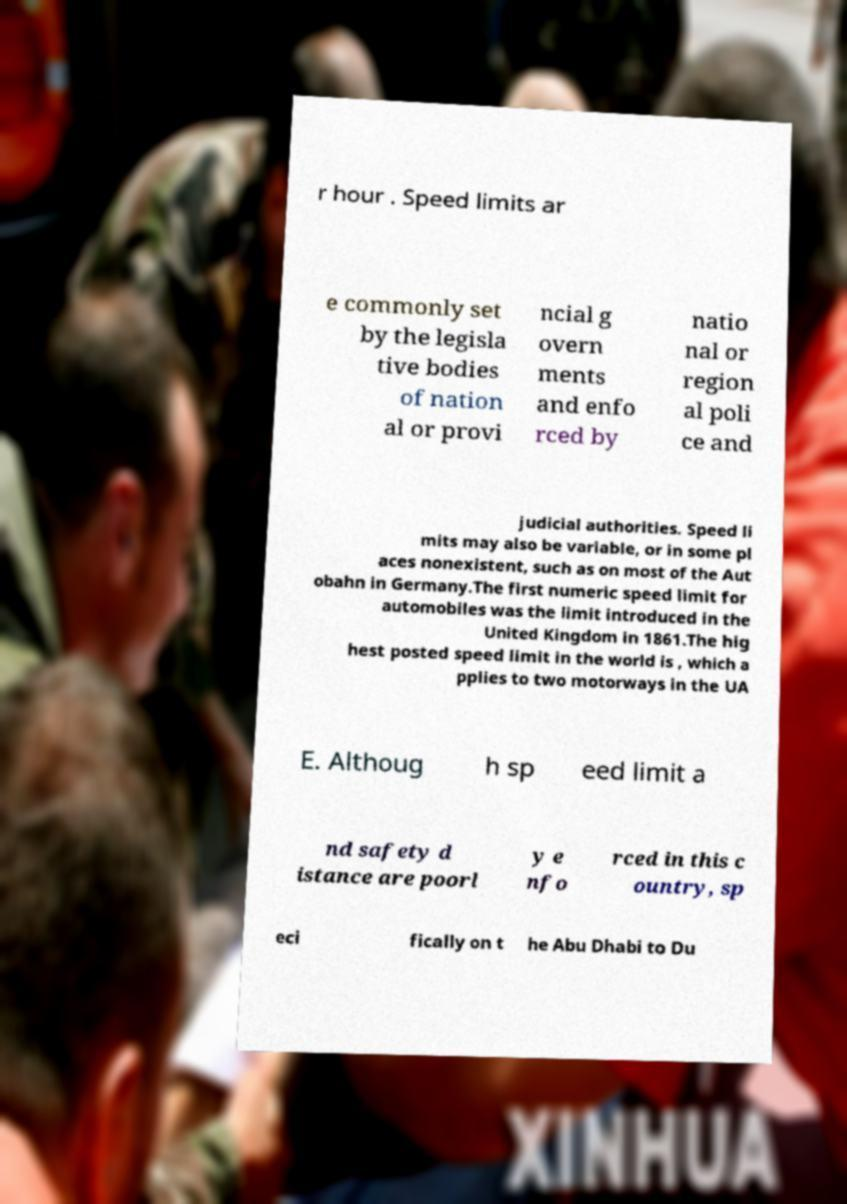Please identify and transcribe the text found in this image. r hour . Speed limits ar e commonly set by the legisla tive bodies of nation al or provi ncial g overn ments and enfo rced by natio nal or region al poli ce and judicial authorities. Speed li mits may also be variable, or in some pl aces nonexistent, such as on most of the Aut obahn in Germany.The first numeric speed limit for automobiles was the limit introduced in the United Kingdom in 1861.The hig hest posted speed limit in the world is , which a pplies to two motorways in the UA E. Althoug h sp eed limit a nd safety d istance are poorl y e nfo rced in this c ountry, sp eci fically on t he Abu Dhabi to Du 